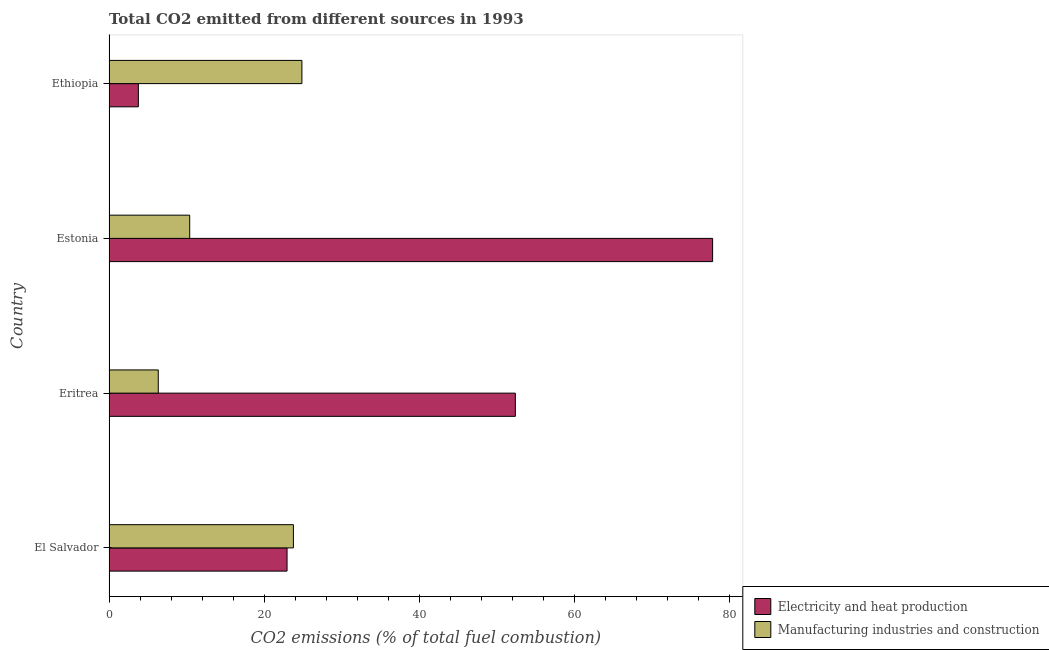How many bars are there on the 4th tick from the bottom?
Your answer should be very brief. 2. What is the label of the 2nd group of bars from the top?
Give a very brief answer. Estonia. What is the co2 emissions due to manufacturing industries in Estonia?
Your answer should be compact. 10.4. Across all countries, what is the maximum co2 emissions due to electricity and heat production?
Your answer should be compact. 77.81. Across all countries, what is the minimum co2 emissions due to electricity and heat production?
Ensure brevity in your answer.  3.78. In which country was the co2 emissions due to manufacturing industries maximum?
Your answer should be very brief. Ethiopia. In which country was the co2 emissions due to electricity and heat production minimum?
Give a very brief answer. Ethiopia. What is the total co2 emissions due to manufacturing industries in the graph?
Your answer should be compact. 65.39. What is the difference between the co2 emissions due to manufacturing industries in Eritrea and that in Ethiopia?
Your response must be concise. -18.52. What is the difference between the co2 emissions due to manufacturing industries in Estonia and the co2 emissions due to electricity and heat production in Eritrea?
Ensure brevity in your answer.  -41.98. What is the average co2 emissions due to manufacturing industries per country?
Your answer should be compact. 16.35. What is the difference between the co2 emissions due to manufacturing industries and co2 emissions due to electricity and heat production in Eritrea?
Keep it short and to the point. -46.03. What is the ratio of the co2 emissions due to electricity and heat production in Eritrea to that in Ethiopia?
Give a very brief answer. 13.84. Is the co2 emissions due to manufacturing industries in Estonia less than that in Ethiopia?
Ensure brevity in your answer.  Yes. Is the difference between the co2 emissions due to manufacturing industries in Eritrea and Estonia greater than the difference between the co2 emissions due to electricity and heat production in Eritrea and Estonia?
Offer a very short reply. Yes. What is the difference between the highest and the second highest co2 emissions due to electricity and heat production?
Give a very brief answer. 25.43. What is the difference between the highest and the lowest co2 emissions due to manufacturing industries?
Give a very brief answer. 18.52. In how many countries, is the co2 emissions due to electricity and heat production greater than the average co2 emissions due to electricity and heat production taken over all countries?
Ensure brevity in your answer.  2. What does the 1st bar from the top in Estonia represents?
Keep it short and to the point. Manufacturing industries and construction. What does the 1st bar from the bottom in Eritrea represents?
Your answer should be very brief. Electricity and heat production. How many bars are there?
Ensure brevity in your answer.  8. What is the difference between two consecutive major ticks on the X-axis?
Keep it short and to the point. 20. Does the graph contain any zero values?
Your answer should be compact. No. Does the graph contain grids?
Offer a terse response. No. Where does the legend appear in the graph?
Make the answer very short. Bottom right. How many legend labels are there?
Your answer should be very brief. 2. What is the title of the graph?
Keep it short and to the point. Total CO2 emitted from different sources in 1993. What is the label or title of the X-axis?
Offer a terse response. CO2 emissions (% of total fuel combustion). What is the label or title of the Y-axis?
Offer a terse response. Country. What is the CO2 emissions (% of total fuel combustion) of Electricity and heat production in El Salvador?
Provide a succinct answer. 22.95. What is the CO2 emissions (% of total fuel combustion) in Manufacturing industries and construction in El Salvador?
Keep it short and to the point. 23.77. What is the CO2 emissions (% of total fuel combustion) in Electricity and heat production in Eritrea?
Ensure brevity in your answer.  52.38. What is the CO2 emissions (% of total fuel combustion) of Manufacturing industries and construction in Eritrea?
Provide a short and direct response. 6.35. What is the CO2 emissions (% of total fuel combustion) in Electricity and heat production in Estonia?
Provide a succinct answer. 77.81. What is the CO2 emissions (% of total fuel combustion) of Manufacturing industries and construction in Estonia?
Provide a succinct answer. 10.4. What is the CO2 emissions (% of total fuel combustion) of Electricity and heat production in Ethiopia?
Make the answer very short. 3.78. What is the CO2 emissions (% of total fuel combustion) in Manufacturing industries and construction in Ethiopia?
Your answer should be compact. 24.86. Across all countries, what is the maximum CO2 emissions (% of total fuel combustion) in Electricity and heat production?
Provide a short and direct response. 77.81. Across all countries, what is the maximum CO2 emissions (% of total fuel combustion) of Manufacturing industries and construction?
Your answer should be compact. 24.86. Across all countries, what is the minimum CO2 emissions (% of total fuel combustion) in Electricity and heat production?
Offer a terse response. 3.78. Across all countries, what is the minimum CO2 emissions (% of total fuel combustion) of Manufacturing industries and construction?
Your response must be concise. 6.35. What is the total CO2 emissions (% of total fuel combustion) of Electricity and heat production in the graph?
Provide a short and direct response. 156.92. What is the total CO2 emissions (% of total fuel combustion) in Manufacturing industries and construction in the graph?
Keep it short and to the point. 65.39. What is the difference between the CO2 emissions (% of total fuel combustion) of Electricity and heat production in El Salvador and that in Eritrea?
Give a very brief answer. -29.43. What is the difference between the CO2 emissions (% of total fuel combustion) in Manufacturing industries and construction in El Salvador and that in Eritrea?
Your answer should be compact. 17.42. What is the difference between the CO2 emissions (% of total fuel combustion) of Electricity and heat production in El Salvador and that in Estonia?
Keep it short and to the point. -54.86. What is the difference between the CO2 emissions (% of total fuel combustion) of Manufacturing industries and construction in El Salvador and that in Estonia?
Offer a very short reply. 13.37. What is the difference between the CO2 emissions (% of total fuel combustion) in Electricity and heat production in El Salvador and that in Ethiopia?
Your answer should be compact. 19.17. What is the difference between the CO2 emissions (% of total fuel combustion) in Manufacturing industries and construction in El Salvador and that in Ethiopia?
Ensure brevity in your answer.  -1.09. What is the difference between the CO2 emissions (% of total fuel combustion) of Electricity and heat production in Eritrea and that in Estonia?
Ensure brevity in your answer.  -25.43. What is the difference between the CO2 emissions (% of total fuel combustion) in Manufacturing industries and construction in Eritrea and that in Estonia?
Offer a terse response. -4.05. What is the difference between the CO2 emissions (% of total fuel combustion) in Electricity and heat production in Eritrea and that in Ethiopia?
Give a very brief answer. 48.6. What is the difference between the CO2 emissions (% of total fuel combustion) of Manufacturing industries and construction in Eritrea and that in Ethiopia?
Keep it short and to the point. -18.52. What is the difference between the CO2 emissions (% of total fuel combustion) in Electricity and heat production in Estonia and that in Ethiopia?
Provide a succinct answer. 74.02. What is the difference between the CO2 emissions (% of total fuel combustion) in Manufacturing industries and construction in Estonia and that in Ethiopia?
Offer a terse response. -14.46. What is the difference between the CO2 emissions (% of total fuel combustion) in Electricity and heat production in El Salvador and the CO2 emissions (% of total fuel combustion) in Manufacturing industries and construction in Eritrea?
Provide a short and direct response. 16.6. What is the difference between the CO2 emissions (% of total fuel combustion) in Electricity and heat production in El Salvador and the CO2 emissions (% of total fuel combustion) in Manufacturing industries and construction in Estonia?
Make the answer very short. 12.55. What is the difference between the CO2 emissions (% of total fuel combustion) of Electricity and heat production in El Salvador and the CO2 emissions (% of total fuel combustion) of Manufacturing industries and construction in Ethiopia?
Offer a terse response. -1.91. What is the difference between the CO2 emissions (% of total fuel combustion) in Electricity and heat production in Eritrea and the CO2 emissions (% of total fuel combustion) in Manufacturing industries and construction in Estonia?
Your answer should be compact. 41.98. What is the difference between the CO2 emissions (% of total fuel combustion) of Electricity and heat production in Eritrea and the CO2 emissions (% of total fuel combustion) of Manufacturing industries and construction in Ethiopia?
Ensure brevity in your answer.  27.52. What is the difference between the CO2 emissions (% of total fuel combustion) of Electricity and heat production in Estonia and the CO2 emissions (% of total fuel combustion) of Manufacturing industries and construction in Ethiopia?
Make the answer very short. 52.94. What is the average CO2 emissions (% of total fuel combustion) of Electricity and heat production per country?
Provide a short and direct response. 39.23. What is the average CO2 emissions (% of total fuel combustion) in Manufacturing industries and construction per country?
Your answer should be very brief. 16.35. What is the difference between the CO2 emissions (% of total fuel combustion) of Electricity and heat production and CO2 emissions (% of total fuel combustion) of Manufacturing industries and construction in El Salvador?
Keep it short and to the point. -0.82. What is the difference between the CO2 emissions (% of total fuel combustion) of Electricity and heat production and CO2 emissions (% of total fuel combustion) of Manufacturing industries and construction in Eritrea?
Your answer should be compact. 46.03. What is the difference between the CO2 emissions (% of total fuel combustion) of Electricity and heat production and CO2 emissions (% of total fuel combustion) of Manufacturing industries and construction in Estonia?
Give a very brief answer. 67.41. What is the difference between the CO2 emissions (% of total fuel combustion) of Electricity and heat production and CO2 emissions (% of total fuel combustion) of Manufacturing industries and construction in Ethiopia?
Give a very brief answer. -21.08. What is the ratio of the CO2 emissions (% of total fuel combustion) in Electricity and heat production in El Salvador to that in Eritrea?
Your response must be concise. 0.44. What is the ratio of the CO2 emissions (% of total fuel combustion) in Manufacturing industries and construction in El Salvador to that in Eritrea?
Your response must be concise. 3.74. What is the ratio of the CO2 emissions (% of total fuel combustion) of Electricity and heat production in El Salvador to that in Estonia?
Keep it short and to the point. 0.29. What is the ratio of the CO2 emissions (% of total fuel combustion) in Manufacturing industries and construction in El Salvador to that in Estonia?
Ensure brevity in your answer.  2.29. What is the ratio of the CO2 emissions (% of total fuel combustion) in Electricity and heat production in El Salvador to that in Ethiopia?
Offer a terse response. 6.07. What is the ratio of the CO2 emissions (% of total fuel combustion) in Manufacturing industries and construction in El Salvador to that in Ethiopia?
Your answer should be very brief. 0.96. What is the ratio of the CO2 emissions (% of total fuel combustion) in Electricity and heat production in Eritrea to that in Estonia?
Offer a very short reply. 0.67. What is the ratio of the CO2 emissions (% of total fuel combustion) in Manufacturing industries and construction in Eritrea to that in Estonia?
Your answer should be very brief. 0.61. What is the ratio of the CO2 emissions (% of total fuel combustion) of Electricity and heat production in Eritrea to that in Ethiopia?
Offer a terse response. 13.84. What is the ratio of the CO2 emissions (% of total fuel combustion) of Manufacturing industries and construction in Eritrea to that in Ethiopia?
Ensure brevity in your answer.  0.26. What is the ratio of the CO2 emissions (% of total fuel combustion) in Electricity and heat production in Estonia to that in Ethiopia?
Offer a terse response. 20.56. What is the ratio of the CO2 emissions (% of total fuel combustion) of Manufacturing industries and construction in Estonia to that in Ethiopia?
Keep it short and to the point. 0.42. What is the difference between the highest and the second highest CO2 emissions (% of total fuel combustion) of Electricity and heat production?
Make the answer very short. 25.43. What is the difference between the highest and the second highest CO2 emissions (% of total fuel combustion) in Manufacturing industries and construction?
Your answer should be very brief. 1.09. What is the difference between the highest and the lowest CO2 emissions (% of total fuel combustion) of Electricity and heat production?
Give a very brief answer. 74.02. What is the difference between the highest and the lowest CO2 emissions (% of total fuel combustion) of Manufacturing industries and construction?
Ensure brevity in your answer.  18.52. 